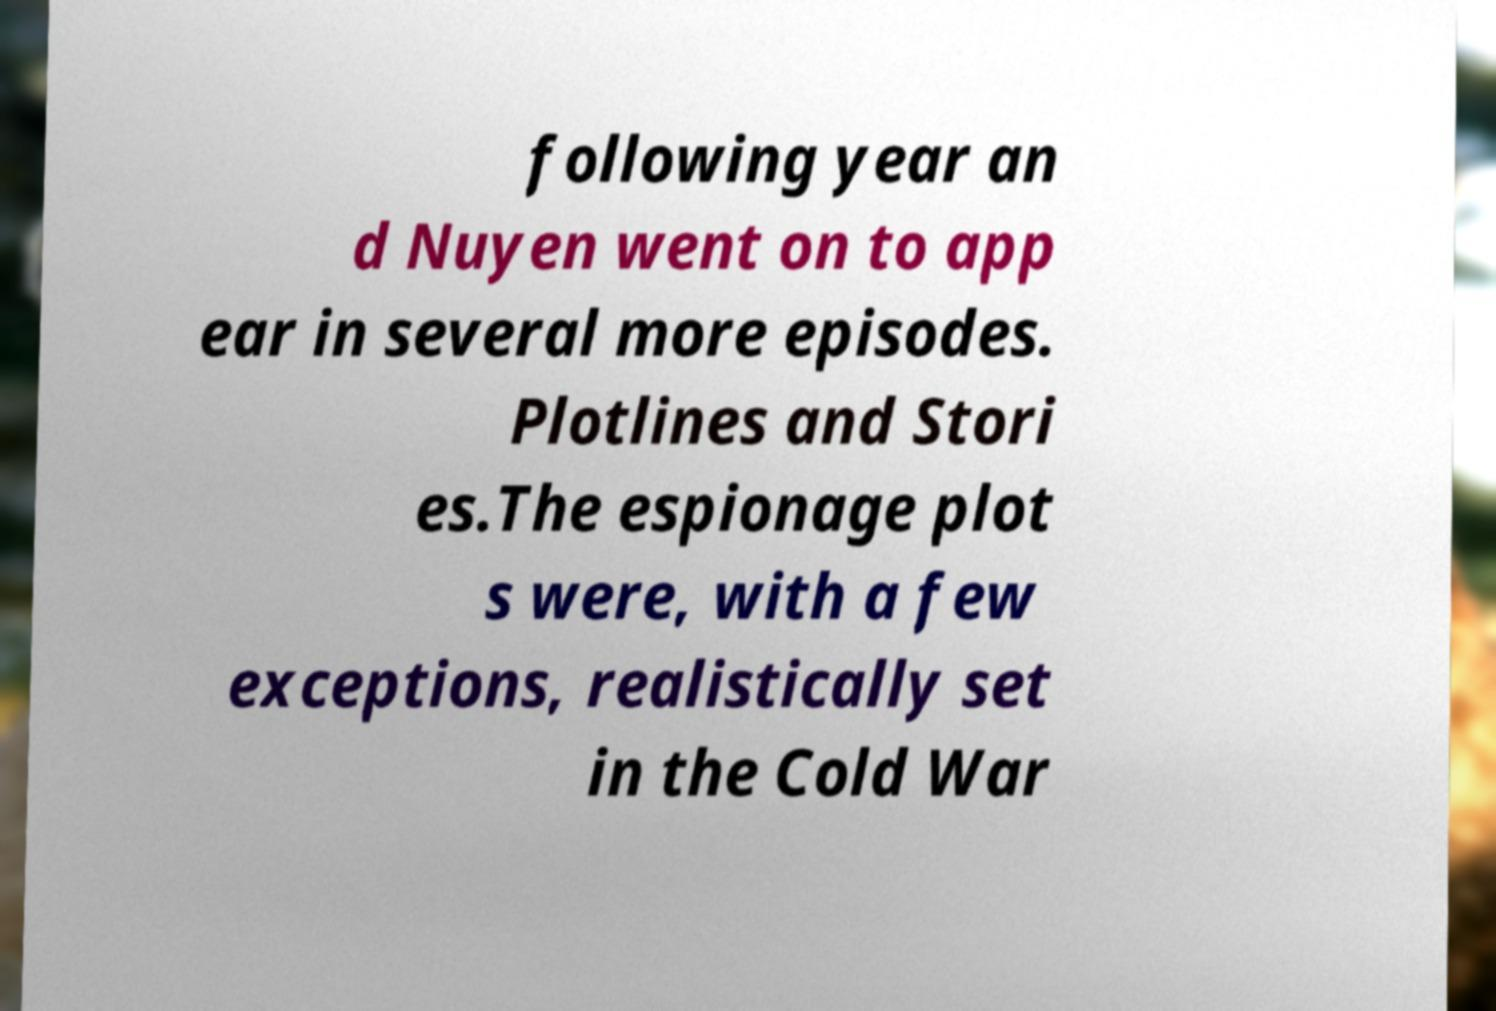Could you extract and type out the text from this image? following year an d Nuyen went on to app ear in several more episodes. Plotlines and Stori es.The espionage plot s were, with a few exceptions, realistically set in the Cold War 